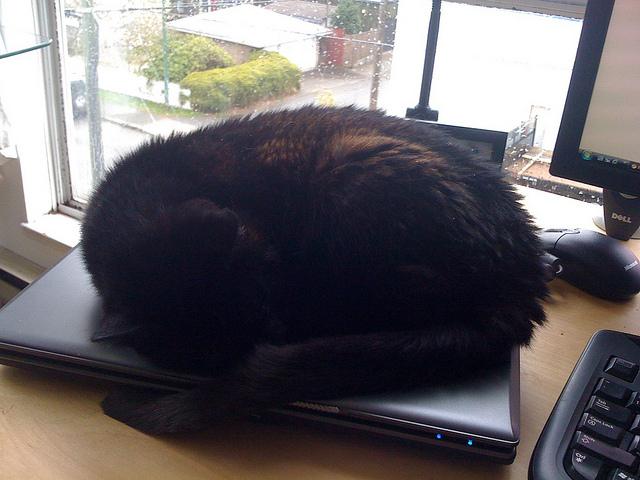Is the cat sitting up?
Give a very brief answer. No. What is the cat laying on?
Be succinct. Laptop. Is the desk near a window?
Keep it brief. Yes. What is on the laptop?
Be succinct. Cat. Is the animal helping or bothering?
Keep it brief. Bothering. 